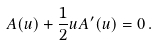Convert formula to latex. <formula><loc_0><loc_0><loc_500><loc_500>A ( u ) + \frac { 1 } { 2 } u A ^ { \prime } ( u ) = 0 \, .</formula> 